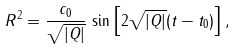<formula> <loc_0><loc_0><loc_500><loc_500>R ^ { 2 } = { \frac { c _ { 0 } } { \sqrt { | Q | } } } \, \sin \left [ 2 \sqrt { | Q | } ( t - t _ { 0 } ) \right ] ,</formula> 